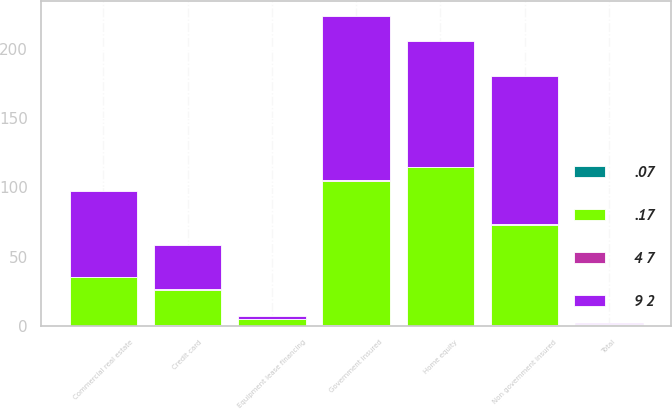<chart> <loc_0><loc_0><loc_500><loc_500><stacked_bar_chart><ecel><fcel>Commercial real estate<fcel>Equipment lease financing<fcel>Home equity<fcel>Non government insured<fcel>Government insured<fcel>Credit card<fcel>Total<nl><fcel>.17<fcel>35<fcel>5<fcel>114<fcel>72<fcel>104<fcel>25<fcel>0.78<nl><fcel>9 2<fcel>62<fcel>2<fcel>91<fcel>107<fcel>118<fcel>32<fcel>0.78<nl><fcel>4 7<fcel>0.22<fcel>0.08<fcel>0.34<fcel>0.5<fcel>0.72<fcel>0.63<fcel>0.34<nl><fcel>.07<fcel>0.35<fcel>0.03<fcel>0.27<fcel>0.67<fcel>0.74<fcel>0.82<fcel>0.4<nl></chart> 